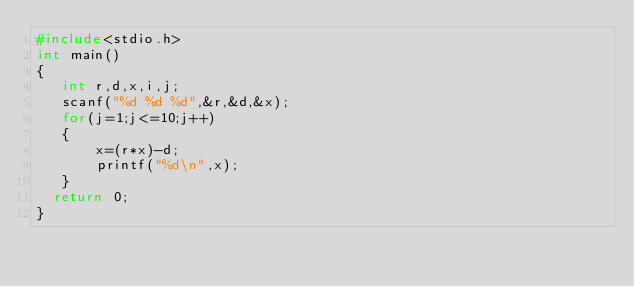Convert code to text. <code><loc_0><loc_0><loc_500><loc_500><_C_>#include<stdio.h>
int main()
{
   int r,d,x,i,j;
   scanf("%d %d %d",&r,&d,&x);
   for(j=1;j<=10;j++)
   {
       x=(r*x)-d;
       printf("%d\n",x);
   }
  return 0;
}
</code> 